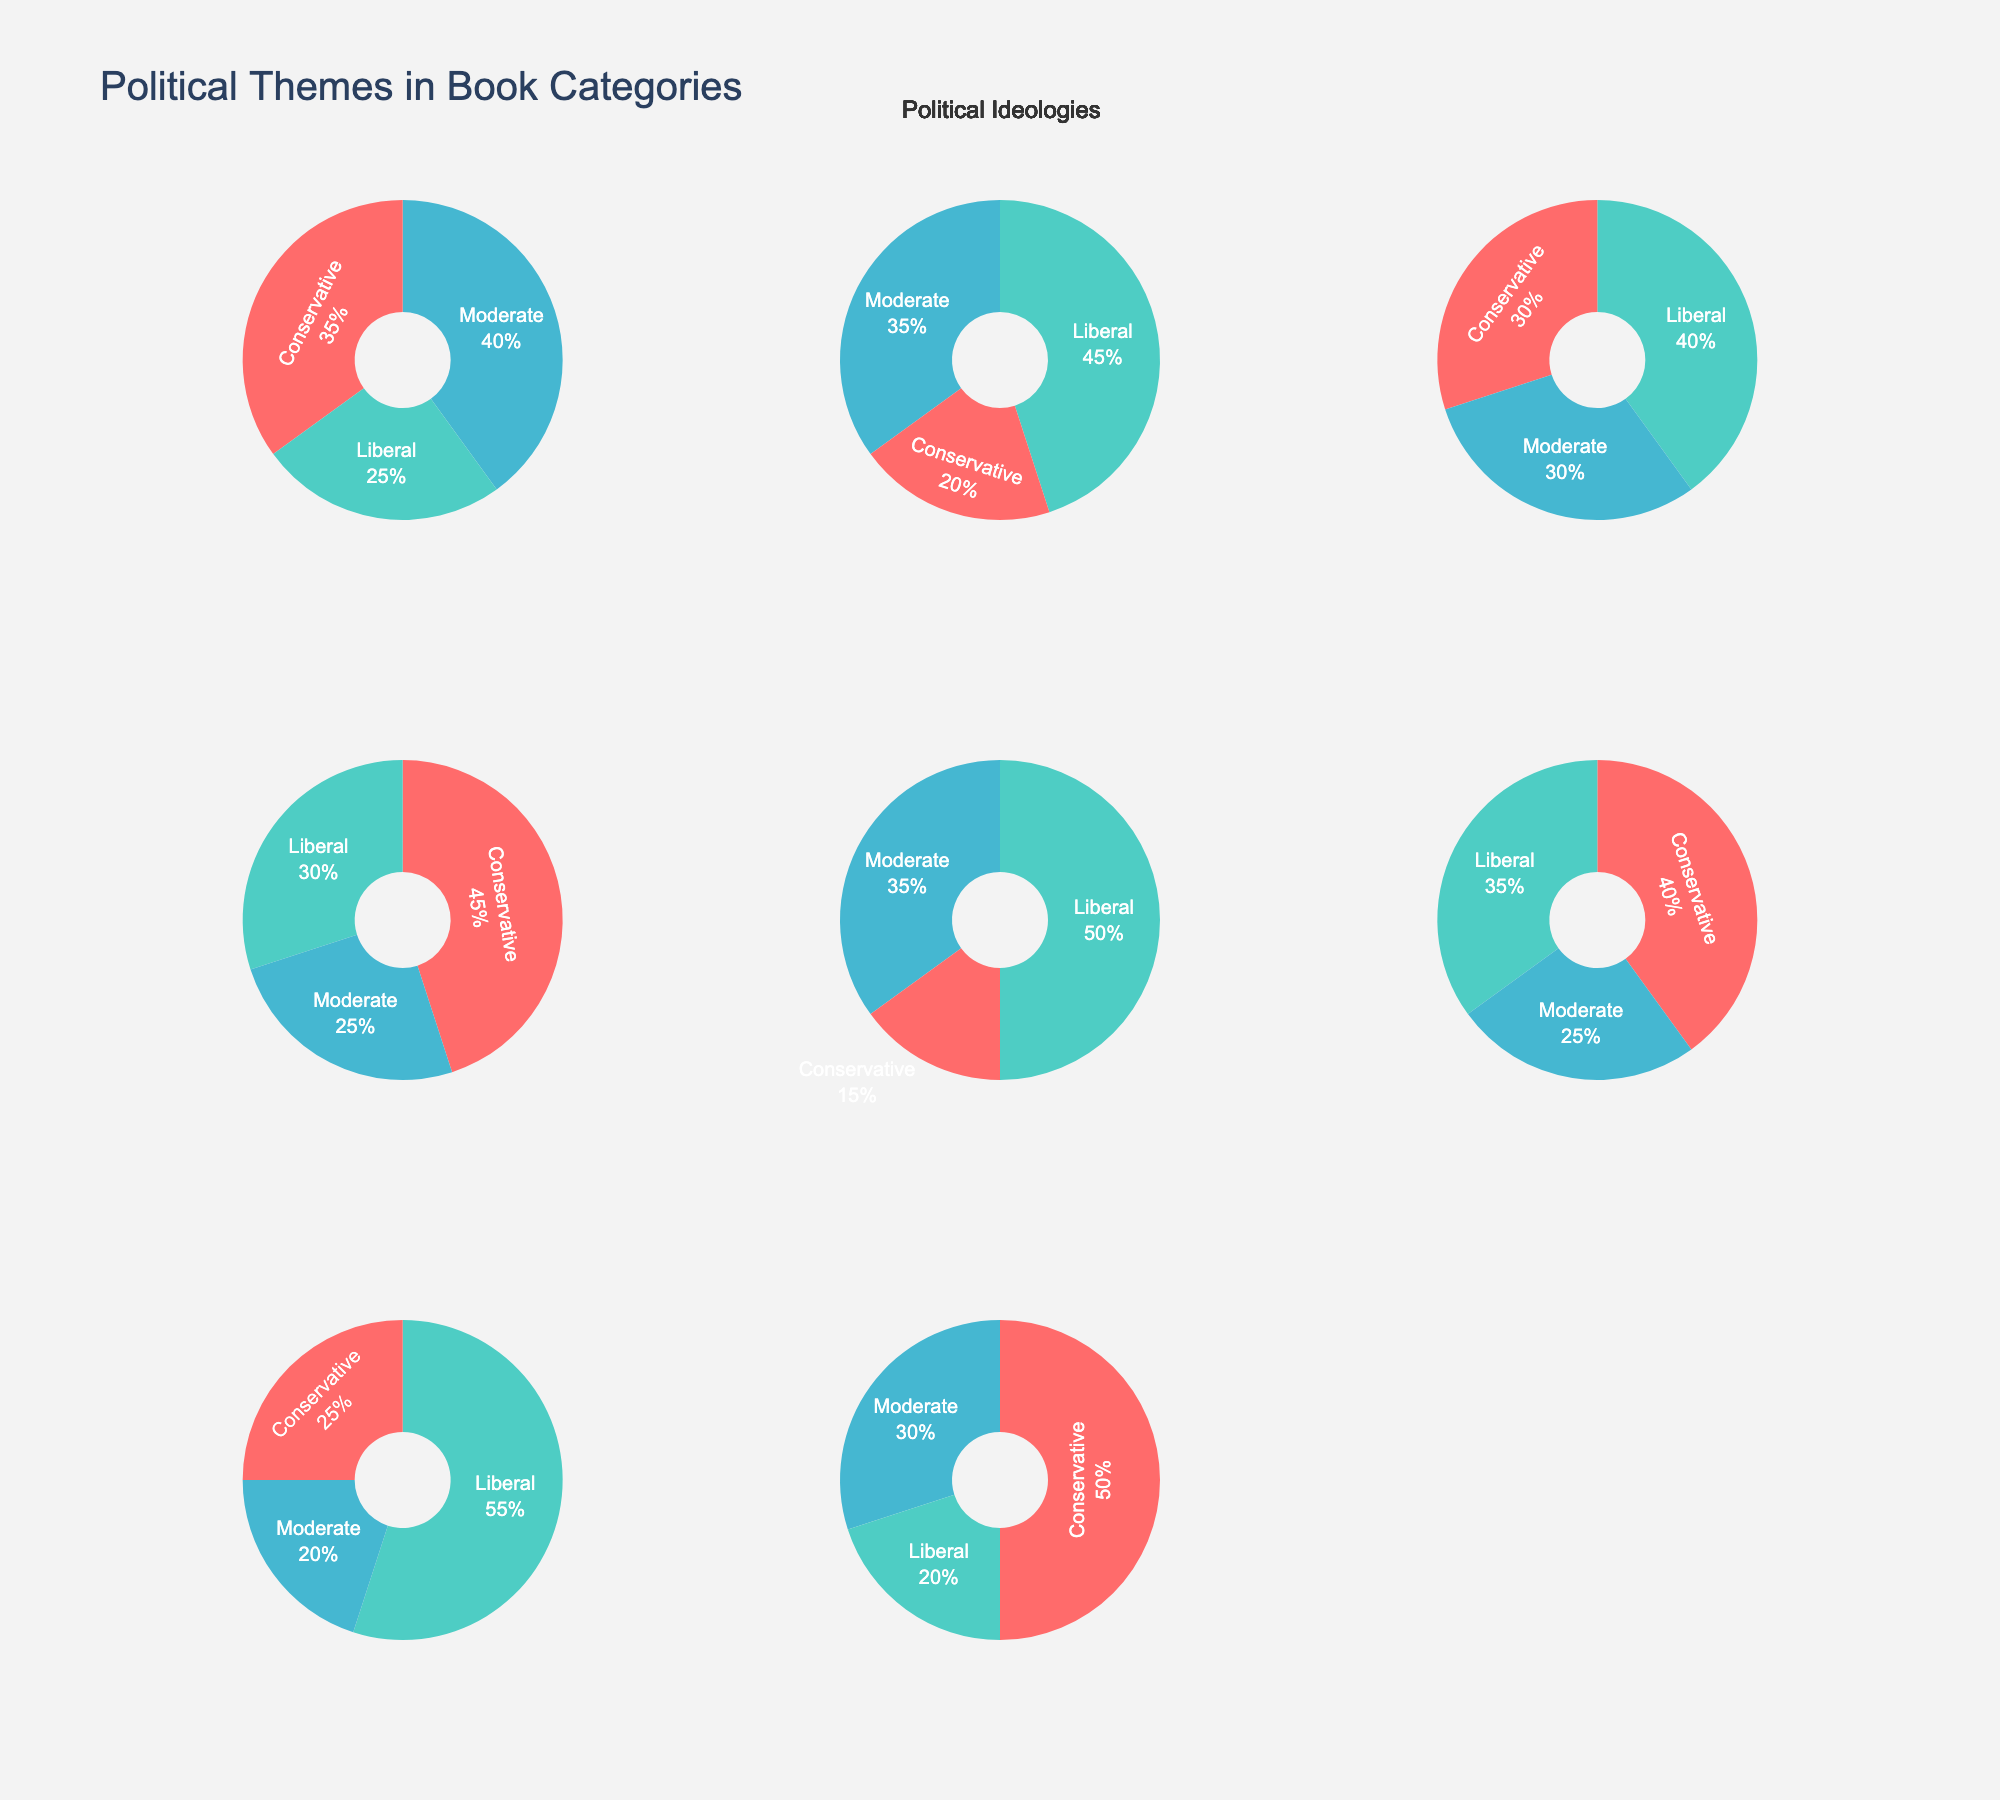What's the largest percentage of Conservative representation in any book category? By examining the pie charts, we observe that 'War Novels' has the highest Conservative representation. The percentage value for Conservative is the largest piece of the pie chart compared to other categories.
Answer: 50% Which book category shows the highest Liberal representation? Inspecting the pie charts, we can notice that 'Social Commentary' has the highest percentage of Liberal representation, evident from the largest portion of the pie.
Answer: Social Commentary What's the difference in Conservative representation between 'Political Thrillers' and 'Biographies'? From the pie charts, Conservative representation in 'Political Thrillers' is 45% while in 'Biographies' it is 40%. The difference is calculated as 45% - 40%.
Answer: 5% Which categories have equal representation for Moderates? By comparing the pie charts, we can see that both 'Literary Fiction' and 'Historical Fiction' have a 30% representation for Moderates, indicated by equal portions in their respective charts.
Answer: Literary Fiction, Historical Fiction What is the combined percentage of Conservative and Liberal representations in 'Science Fiction'? From the 'Science Fiction' pie chart, adding the Conservative (20%) and Liberal (45%) percentages gives us 20% + 45%.
Answer: 65% In which category is the smallest percentage representation for any political ideologies? Observing all pie charts, the smallest percentages for any ideology are conservatives in 'Dystopian', which is 15%.
Answer: Dystopian Which category has the most equal representation across all three political ideologies? By looking at the segments in the pie charts, 'Literary Fiction' has the most balanced representations with Conservative (30%), Liberal (40%), and Moderate (30%) percentages.
Answer: Literary Fiction How many categories have a Liberal representation greater than 35%? Examining each pie chart for the Liberal segment, we find that 'Science Fiction', 'Literary Fiction', 'Dystopian', and 'Social Commentary' all exceed 35% representation.
Answer: 4 What is the average percentage representation of Moderates across all categories? Summing up the percentages of Moderates across all categories (40, 35, 30, 25, 35, 25, 20, 30) gives 240%. Dividing by the number of categories (8) results in an average: 240% / 8 = 30%.
Answer: 30% Which book category has at least twice the percentage of Conservative representation as that of Liberal? Upon inspecting the pie charts, 'War Novels' have a Conservative representation of 50% and Liberal representation of 20%. Since 50% is at least twice as much as 20%, 'War Novels' fit the criteria.
Answer: War Novels 